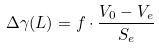Convert formula to latex. <formula><loc_0><loc_0><loc_500><loc_500>\Delta \gamma ( L ) = f \cdot \frac { V _ { 0 } - V _ { e } } { S _ { e } }</formula> 